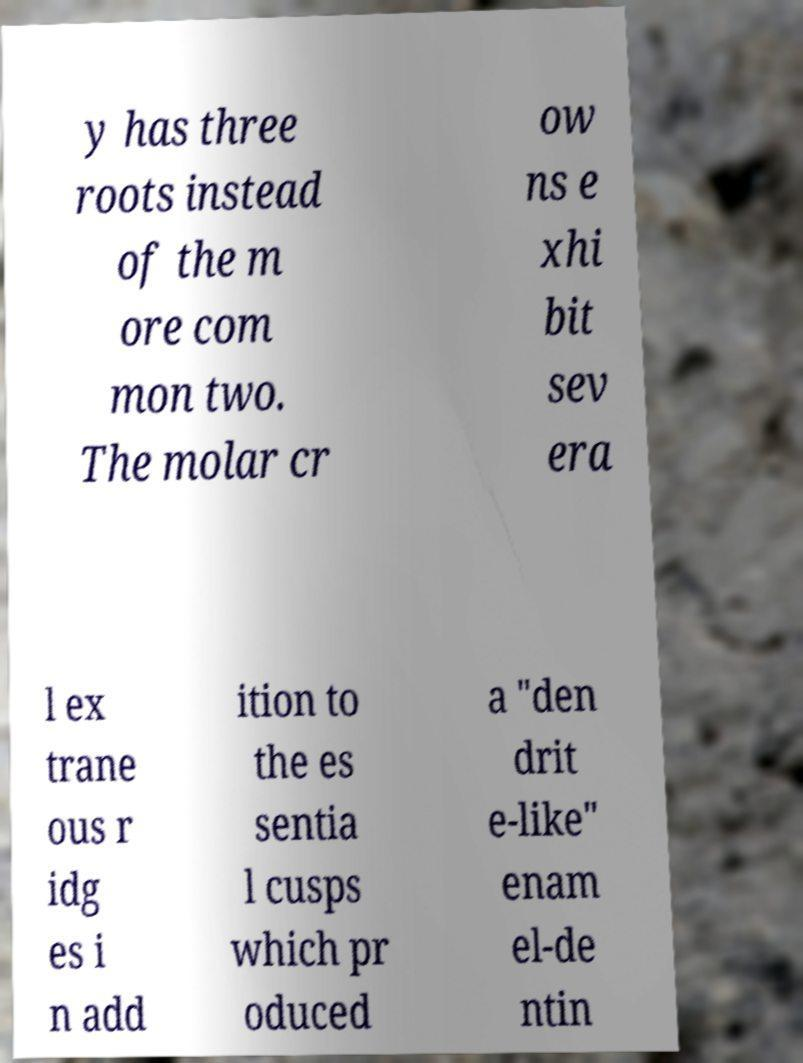Can you read and provide the text displayed in the image?This photo seems to have some interesting text. Can you extract and type it out for me? y has three roots instead of the m ore com mon two. The molar cr ow ns e xhi bit sev era l ex trane ous r idg es i n add ition to the es sentia l cusps which pr oduced a "den drit e-like" enam el-de ntin 